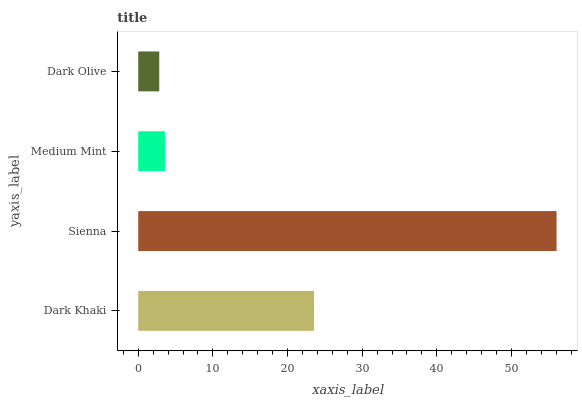Is Dark Olive the minimum?
Answer yes or no. Yes. Is Sienna the maximum?
Answer yes or no. Yes. Is Medium Mint the minimum?
Answer yes or no. No. Is Medium Mint the maximum?
Answer yes or no. No. Is Sienna greater than Medium Mint?
Answer yes or no. Yes. Is Medium Mint less than Sienna?
Answer yes or no. Yes. Is Medium Mint greater than Sienna?
Answer yes or no. No. Is Sienna less than Medium Mint?
Answer yes or no. No. Is Dark Khaki the high median?
Answer yes or no. Yes. Is Medium Mint the low median?
Answer yes or no. Yes. Is Sienna the high median?
Answer yes or no. No. Is Dark Olive the low median?
Answer yes or no. No. 